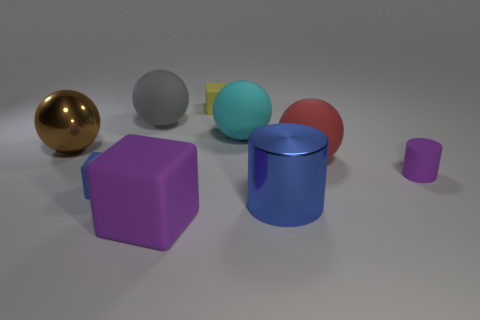Subtract all small cubes. How many cubes are left? 1 Subtract 1 cubes. How many cubes are left? 2 Subtract all red spheres. How many spheres are left? 3 Subtract all yellow balls. Subtract all cyan cubes. How many balls are left? 4 Add 1 large blue blocks. How many objects exist? 10 Subtract all blocks. How many objects are left? 6 Subtract 0 yellow spheres. How many objects are left? 9 Subtract all rubber balls. Subtract all blue cylinders. How many objects are left? 5 Add 7 tiny yellow rubber objects. How many tiny yellow rubber objects are left? 8 Add 2 matte spheres. How many matte spheres exist? 5 